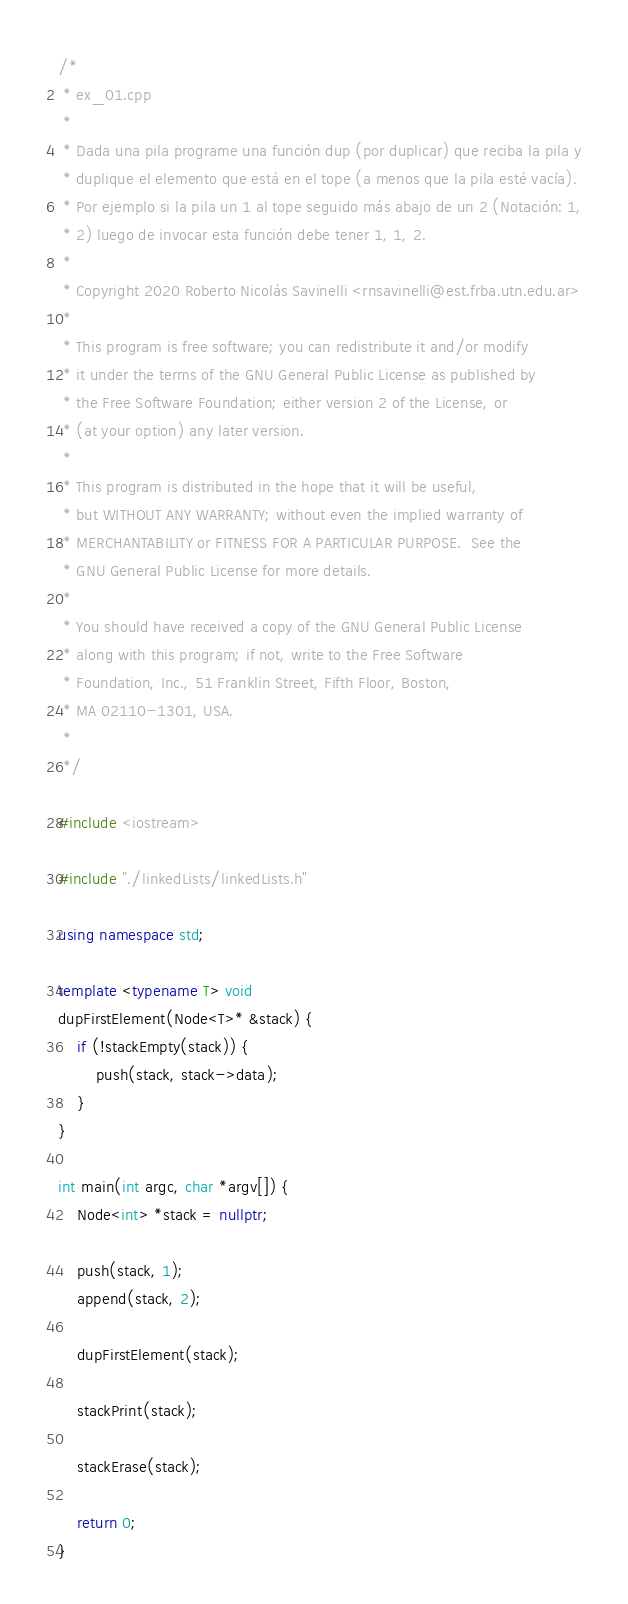Convert code to text. <code><loc_0><loc_0><loc_500><loc_500><_C++_>/*
 * ex_01.cpp
 *
 * Dada una pila programe una función dup (por duplicar) que reciba la pila y
 * duplique el elemento que está en el tope (a menos que la pila esté vacía).
 * Por ejemplo si la pila un 1 al tope seguido más abajo de un 2 (Notación: 1,
 * 2) luego de invocar esta función debe tener 1, 1, 2.
 *
 * Copyright 2020 Roberto Nicolás Savinelli <rnsavinelli@est.frba.utn.edu.ar>
 *
 * This program is free software; you can redistribute it and/or modify
 * it under the terms of the GNU General Public License as published by
 * the Free Software Foundation; either version 2 of the License, or
 * (at your option) any later version.
 *
 * This program is distributed in the hope that it will be useful,
 * but WITHOUT ANY WARRANTY; without even the implied warranty of
 * MERCHANTABILITY or FITNESS FOR A PARTICULAR PURPOSE.  See the
 * GNU General Public License for more details.
 *
 * You should have received a copy of the GNU General Public License
 * along with this program; if not, write to the Free Software
 * Foundation, Inc., 51 Franklin Street, Fifth Floor, Boston,
 * MA 02110-1301, USA.
 *
 */

#include <iostream>

#include "./linkedLists/linkedLists.h"

using namespace std;

template <typename T> void
dupFirstElement(Node<T>* &stack) {
    if (!stackEmpty(stack)) {
        push(stack, stack->data);
    }
}

int main(int argc, char *argv[]) {
    Node<int> *stack = nullptr;

    push(stack, 1);
    append(stack, 2);

    dupFirstElement(stack);

    stackPrint(stack);

    stackErase(stack);

    return 0;
}
</code> 